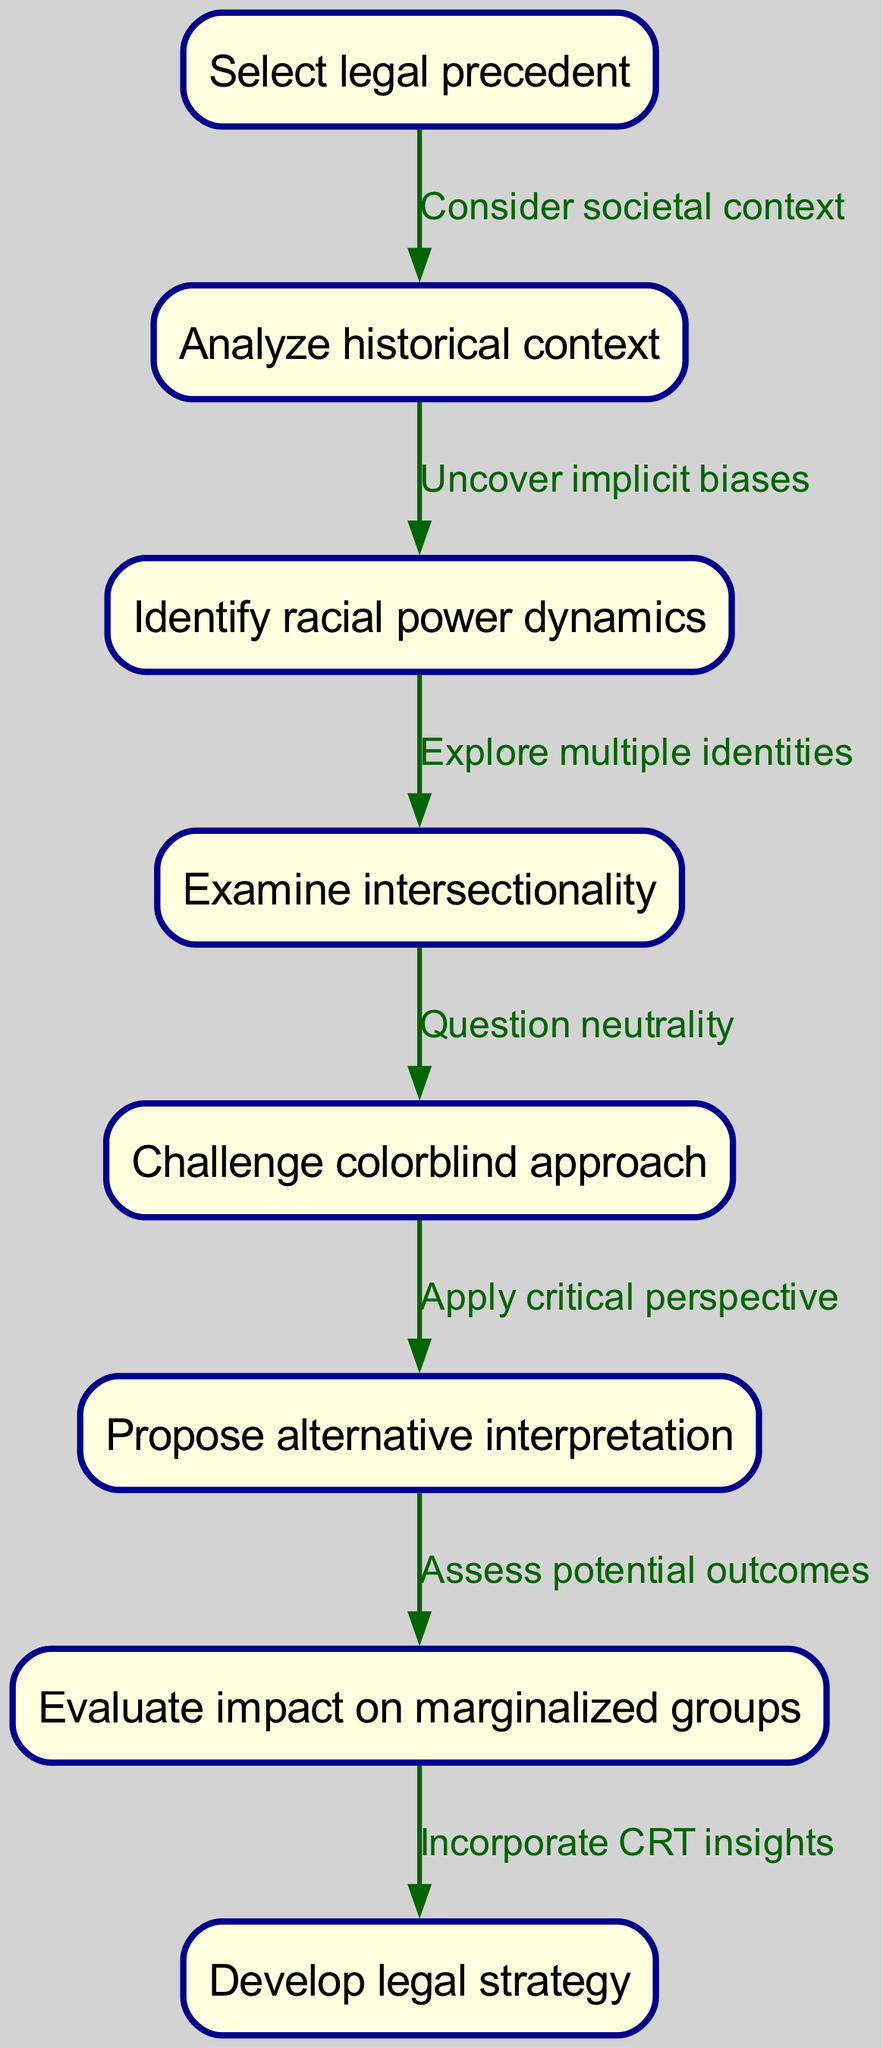What is the first node in the diagram? The first node is labeled "Select legal precedent," which indicates the starting point of the flowchart where the process begins.
Answer: Select legal precedent How many edges are in total in the diagram? By counting all the connections between nodes, there are 7 edges present in the flowchart that connect the different steps of the process.
Answer: 7 What is the last step in the process? The final step is "Develop legal strategy," which signifies the culmination of the analysis process using critical race theory.
Answer: Develop legal strategy What do the edges "Consider societal context" and "Uncover implicit biases" lead to? The edge "Consider societal context" leads from "Select legal precedent" to "Analyze historical context," while "Uncover implicit biases" goes from "Analyze historical context" to "Identify racial power dynamics," indicating the flow of thought and analysis.
Answer: Analyze historical context, Identify racial power dynamics Which node examines multiple identities? The node "Examine intersectionality" is the part of the process where multiple identities are explored, contributing to a deeper understanding of racial dynamics within legal precedents.
Answer: Examine intersectionality How does one challenge neutrality in the analysis? One challenges neutrality through the "Question neutrality" edge that connects "Examine intersectionality" to "Challenge colorblind approach," indicating a critical stance against perceived impartiality.
Answer: Question neutrality What alternative does the flowchart suggest after the challenge? After challenging the colorblind approach, the flowchart suggests to "Propose alternative interpretation," pointing towards a constructive next step in the critical analysis.
Answer: Propose alternative interpretation Which step assesses potential outcomes? The step that assesses potential outcomes is "Evaluate impact on marginalized groups," serving as a crucial evaluation point in the analysis process.
Answer: Evaluate impact on marginalized groups 